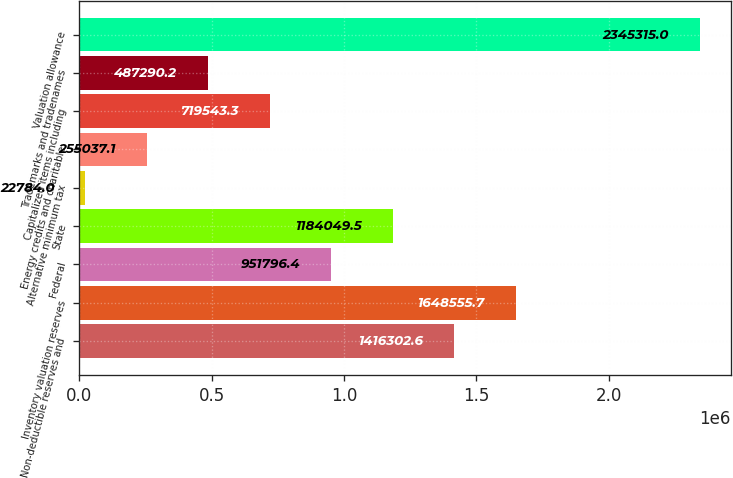<chart> <loc_0><loc_0><loc_500><loc_500><bar_chart><fcel>Non-deductible reserves and<fcel>Inventory valuation reserves<fcel>Federal<fcel>State<fcel>Alternative minimum tax<fcel>Energy credits and charitable<fcel>Capitalized items including<fcel>Trademarks and tradenames<fcel>Valuation allowance<nl><fcel>1.4163e+06<fcel>1.64856e+06<fcel>951796<fcel>1.18405e+06<fcel>22784<fcel>255037<fcel>719543<fcel>487290<fcel>2.34532e+06<nl></chart> 